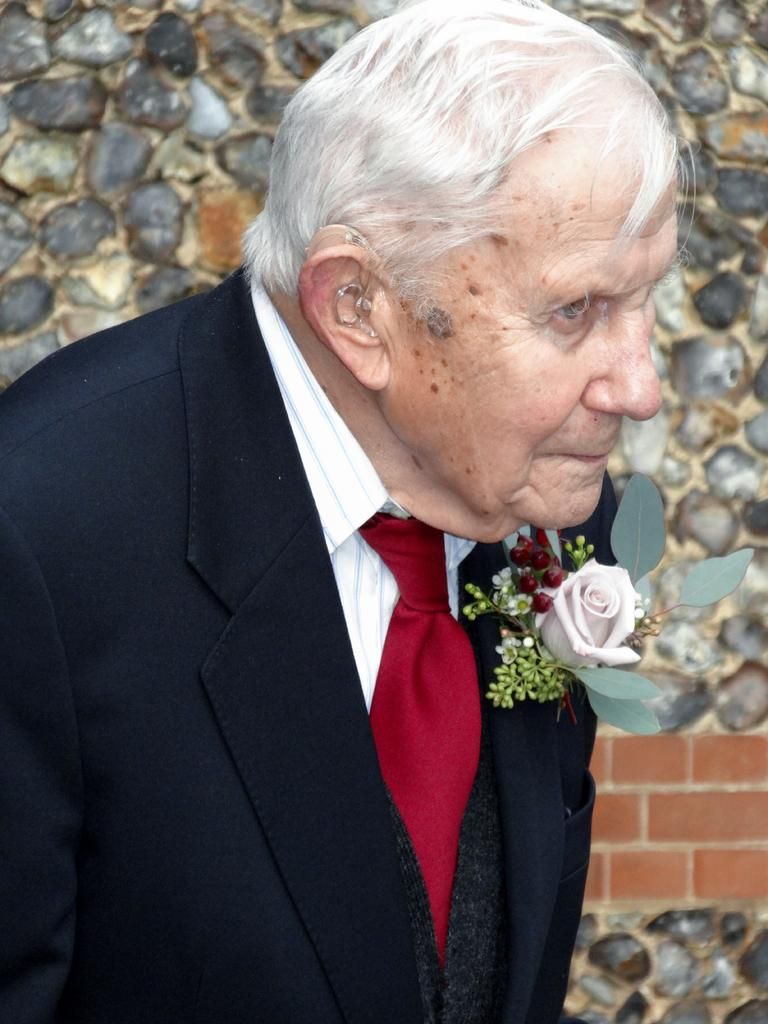Who or what is present in the image? There is a person in the image. Can you describe the person's attire? The person is wearing a dress with black, white, and maroon colors. Are there any specific details about the dress? Yes, there is a flower on the dress. What can be seen in the background of the image? There is a wall in the background of the image. How many cats are sitting on the person's head in the image? There are no cats present in the image. What type of cabbage is being used as a hat by the person in the image? There is no cabbage present in the image, and the person is wearing a dress, not a hat. 